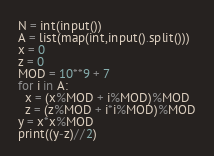Convert code to text. <code><loc_0><loc_0><loc_500><loc_500><_Python_>N = int(input())
A = list(map(int,input().split()))
x = 0
z = 0
MOD = 10**9 + 7
for i in A:
  x = (x%MOD + i%MOD)%MOD
  z = (z%MOD + i*i%MOD)%MOD
y = x*x%MOD
print((y-z)//2)</code> 